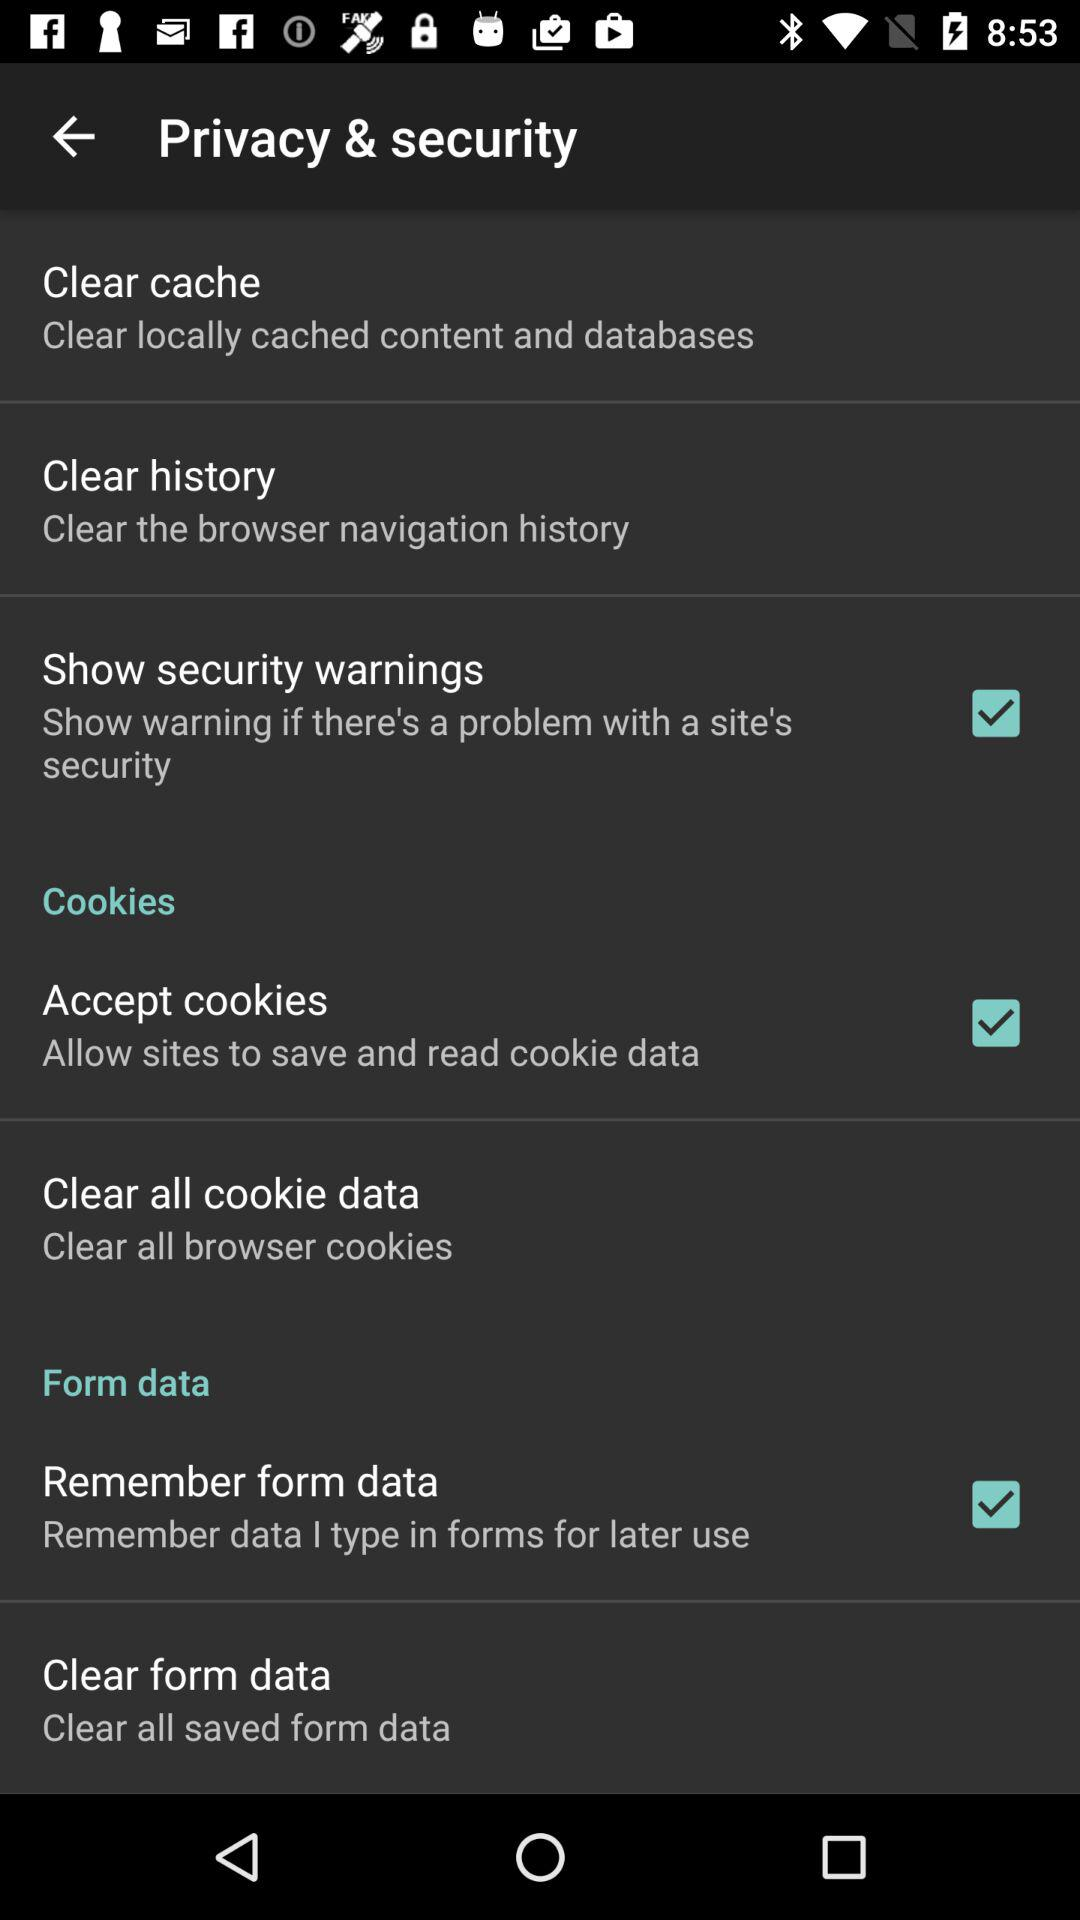What is the status of "Remember form data"? The status is "on". 